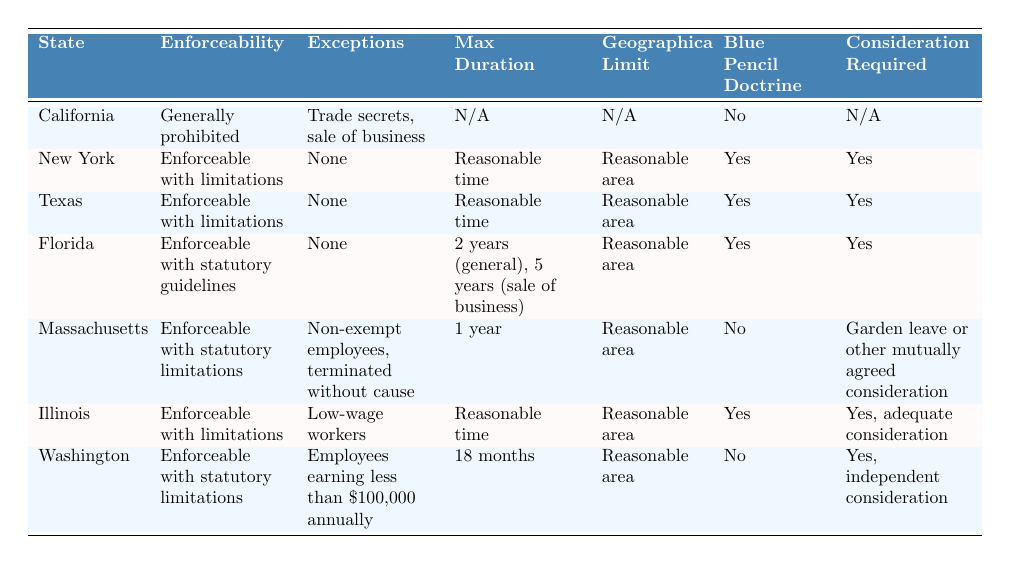What is the enforceability of non-compete agreements in California? According to the table, California's enforceability is "Generally prohibited."
Answer: Generally prohibited Which state allows non-compete agreements with reasonable limitations? The states with "Enforceable with limitations" are New York, Texas, Illinois.
Answer: New York, Texas, Illinois What is the maximum duration of non-compete agreements in Florida? The table states that the max duration can be "2 years (general), 5 years (sale of business)."
Answer: 2 years (general), 5 years (sale of business) Does Massachusetts have exceptions for non-exempt employees? The table indicates that Massachusetts has exceptions for "Non-exempt employees, terminated without cause." So, the answer is yes.
Answer: Yes Which states have a blue pencil doctrine? The table shows that the states with a blue pencil doctrine are New York, Texas, Florida, Illinois.
Answer: New York, Texas, Florida, Illinois How many states generally prohibit non-compete agreements? The table lists only California as a state that "Generally prohibited" non-compete agreements, so the count is 1.
Answer: 1 What is the geographical limit for non-compete agreements in Massachusetts? Based on the table, the geographical limit in Massachusetts is described as "Reasonable area."
Answer: Reasonable area If a worker in Washington earns less than $100,000, what is the enforceability status? The table states that in Washington, for employees earning less than $100,000 annually, non-compete agreements are "Enforceable with statutory limitations."
Answer: Enforceable with statutory limitations In which state is consideration required for non-compete agreements? The table specifies that consideration is required in New York, Texas, Florida, Illinois, and Washington.
Answer: New York, Texas, Florida, Illinois, Washington Which state has the shortest maximum duration for non-compete agreements? Referring to the table, Massachusetts has the shortest maximum duration of "1 year."
Answer: 1 year 